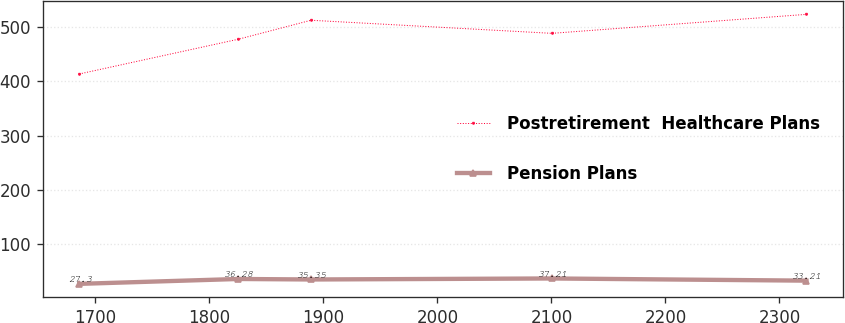Convert chart. <chart><loc_0><loc_0><loc_500><loc_500><line_chart><ecel><fcel>Postretirement  Healthcare Plans<fcel>Pension Plans<nl><fcel>1685.79<fcel>413.42<fcel>27.3<nl><fcel>1825.31<fcel>477.32<fcel>36.28<nl><fcel>1889.11<fcel>512.25<fcel>35.35<nl><fcel>2100.44<fcel>488.17<fcel>37.21<nl><fcel>2323.76<fcel>523.1<fcel>33.21<nl></chart> 